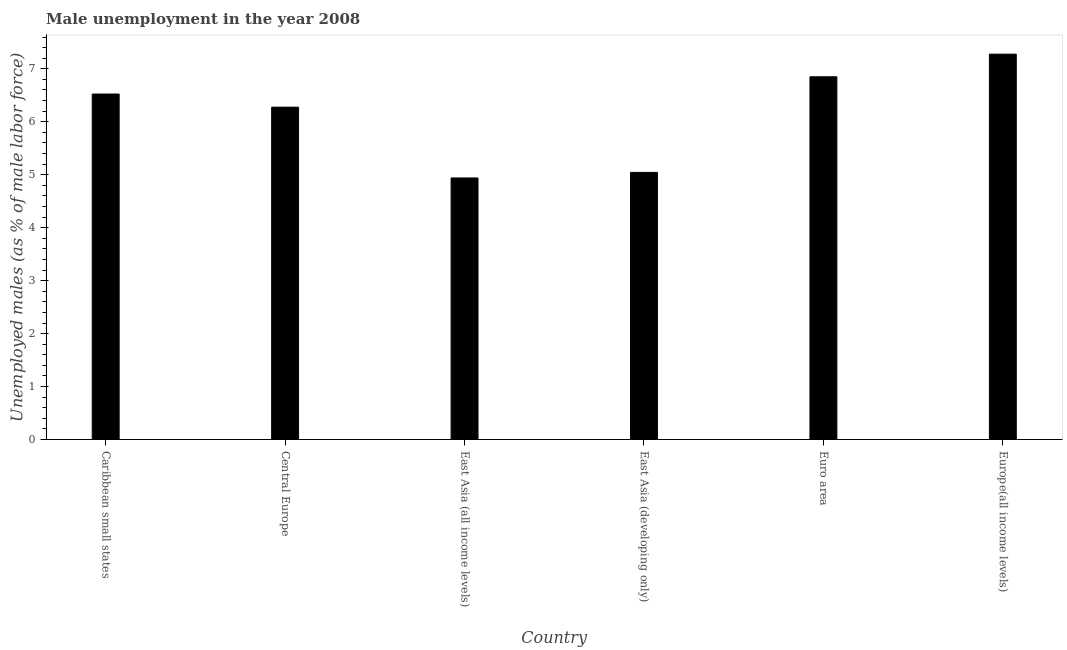Does the graph contain grids?
Provide a short and direct response. No. What is the title of the graph?
Make the answer very short. Male unemployment in the year 2008. What is the label or title of the Y-axis?
Your response must be concise. Unemployed males (as % of male labor force). What is the unemployed males population in East Asia (all income levels)?
Your answer should be very brief. 4.94. Across all countries, what is the maximum unemployed males population?
Give a very brief answer. 7.28. Across all countries, what is the minimum unemployed males population?
Make the answer very short. 4.94. In which country was the unemployed males population maximum?
Your answer should be very brief. Europe(all income levels). In which country was the unemployed males population minimum?
Keep it short and to the point. East Asia (all income levels). What is the sum of the unemployed males population?
Offer a very short reply. 36.91. What is the difference between the unemployed males population in East Asia (all income levels) and Europe(all income levels)?
Your answer should be compact. -2.34. What is the average unemployed males population per country?
Your answer should be very brief. 6.15. What is the median unemployed males population?
Ensure brevity in your answer.  6.4. What is the ratio of the unemployed males population in Caribbean small states to that in Central Europe?
Provide a short and direct response. 1.04. Is the unemployed males population in East Asia (all income levels) less than that in Euro area?
Ensure brevity in your answer.  Yes. Is the difference between the unemployed males population in East Asia (all income levels) and East Asia (developing only) greater than the difference between any two countries?
Offer a very short reply. No. What is the difference between the highest and the second highest unemployed males population?
Your response must be concise. 0.43. Is the sum of the unemployed males population in Central Europe and East Asia (developing only) greater than the maximum unemployed males population across all countries?
Your response must be concise. Yes. What is the difference between the highest and the lowest unemployed males population?
Make the answer very short. 2.34. How many countries are there in the graph?
Give a very brief answer. 6. What is the Unemployed males (as % of male labor force) of Caribbean small states?
Your answer should be compact. 6.52. What is the Unemployed males (as % of male labor force) in Central Europe?
Make the answer very short. 6.28. What is the Unemployed males (as % of male labor force) of East Asia (all income levels)?
Offer a very short reply. 4.94. What is the Unemployed males (as % of male labor force) of East Asia (developing only)?
Give a very brief answer. 5.04. What is the Unemployed males (as % of male labor force) in Euro area?
Give a very brief answer. 6.85. What is the Unemployed males (as % of male labor force) of Europe(all income levels)?
Keep it short and to the point. 7.28. What is the difference between the Unemployed males (as % of male labor force) in Caribbean small states and Central Europe?
Your answer should be compact. 0.25. What is the difference between the Unemployed males (as % of male labor force) in Caribbean small states and East Asia (all income levels)?
Offer a terse response. 1.59. What is the difference between the Unemployed males (as % of male labor force) in Caribbean small states and East Asia (developing only)?
Give a very brief answer. 1.48. What is the difference between the Unemployed males (as % of male labor force) in Caribbean small states and Euro area?
Make the answer very short. -0.33. What is the difference between the Unemployed males (as % of male labor force) in Caribbean small states and Europe(all income levels)?
Provide a short and direct response. -0.75. What is the difference between the Unemployed males (as % of male labor force) in Central Europe and East Asia (all income levels)?
Offer a very short reply. 1.34. What is the difference between the Unemployed males (as % of male labor force) in Central Europe and East Asia (developing only)?
Provide a short and direct response. 1.23. What is the difference between the Unemployed males (as % of male labor force) in Central Europe and Euro area?
Offer a very short reply. -0.57. What is the difference between the Unemployed males (as % of male labor force) in Central Europe and Europe(all income levels)?
Your answer should be very brief. -1. What is the difference between the Unemployed males (as % of male labor force) in East Asia (all income levels) and East Asia (developing only)?
Give a very brief answer. -0.11. What is the difference between the Unemployed males (as % of male labor force) in East Asia (all income levels) and Euro area?
Give a very brief answer. -1.91. What is the difference between the Unemployed males (as % of male labor force) in East Asia (all income levels) and Europe(all income levels)?
Provide a short and direct response. -2.34. What is the difference between the Unemployed males (as % of male labor force) in East Asia (developing only) and Euro area?
Your answer should be compact. -1.8. What is the difference between the Unemployed males (as % of male labor force) in East Asia (developing only) and Europe(all income levels)?
Give a very brief answer. -2.23. What is the difference between the Unemployed males (as % of male labor force) in Euro area and Europe(all income levels)?
Your answer should be compact. -0.43. What is the ratio of the Unemployed males (as % of male labor force) in Caribbean small states to that in Central Europe?
Provide a succinct answer. 1.04. What is the ratio of the Unemployed males (as % of male labor force) in Caribbean small states to that in East Asia (all income levels)?
Offer a terse response. 1.32. What is the ratio of the Unemployed males (as % of male labor force) in Caribbean small states to that in East Asia (developing only)?
Your answer should be compact. 1.29. What is the ratio of the Unemployed males (as % of male labor force) in Caribbean small states to that in Euro area?
Your response must be concise. 0.95. What is the ratio of the Unemployed males (as % of male labor force) in Caribbean small states to that in Europe(all income levels)?
Ensure brevity in your answer.  0.9. What is the ratio of the Unemployed males (as % of male labor force) in Central Europe to that in East Asia (all income levels)?
Provide a succinct answer. 1.27. What is the ratio of the Unemployed males (as % of male labor force) in Central Europe to that in East Asia (developing only)?
Ensure brevity in your answer.  1.24. What is the ratio of the Unemployed males (as % of male labor force) in Central Europe to that in Euro area?
Your response must be concise. 0.92. What is the ratio of the Unemployed males (as % of male labor force) in Central Europe to that in Europe(all income levels)?
Keep it short and to the point. 0.86. What is the ratio of the Unemployed males (as % of male labor force) in East Asia (all income levels) to that in East Asia (developing only)?
Offer a very short reply. 0.98. What is the ratio of the Unemployed males (as % of male labor force) in East Asia (all income levels) to that in Euro area?
Provide a succinct answer. 0.72. What is the ratio of the Unemployed males (as % of male labor force) in East Asia (all income levels) to that in Europe(all income levels)?
Ensure brevity in your answer.  0.68. What is the ratio of the Unemployed males (as % of male labor force) in East Asia (developing only) to that in Euro area?
Your response must be concise. 0.74. What is the ratio of the Unemployed males (as % of male labor force) in East Asia (developing only) to that in Europe(all income levels)?
Your response must be concise. 0.69. What is the ratio of the Unemployed males (as % of male labor force) in Euro area to that in Europe(all income levels)?
Give a very brief answer. 0.94. 